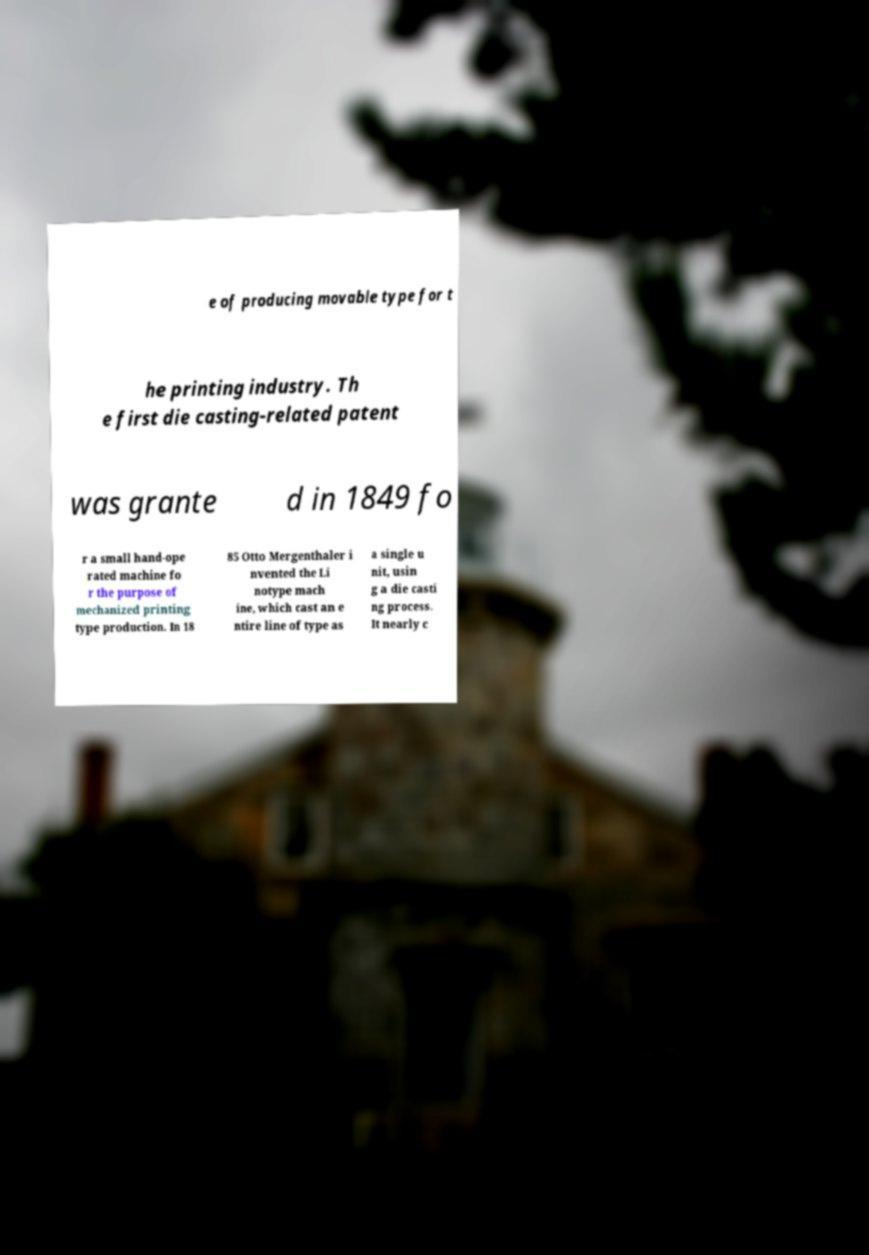For documentation purposes, I need the text within this image transcribed. Could you provide that? e of producing movable type for t he printing industry. Th e first die casting-related patent was grante d in 1849 fo r a small hand-ope rated machine fo r the purpose of mechanized printing type production. In 18 85 Otto Mergenthaler i nvented the Li notype mach ine, which cast an e ntire line of type as a single u nit, usin g a die casti ng process. It nearly c 